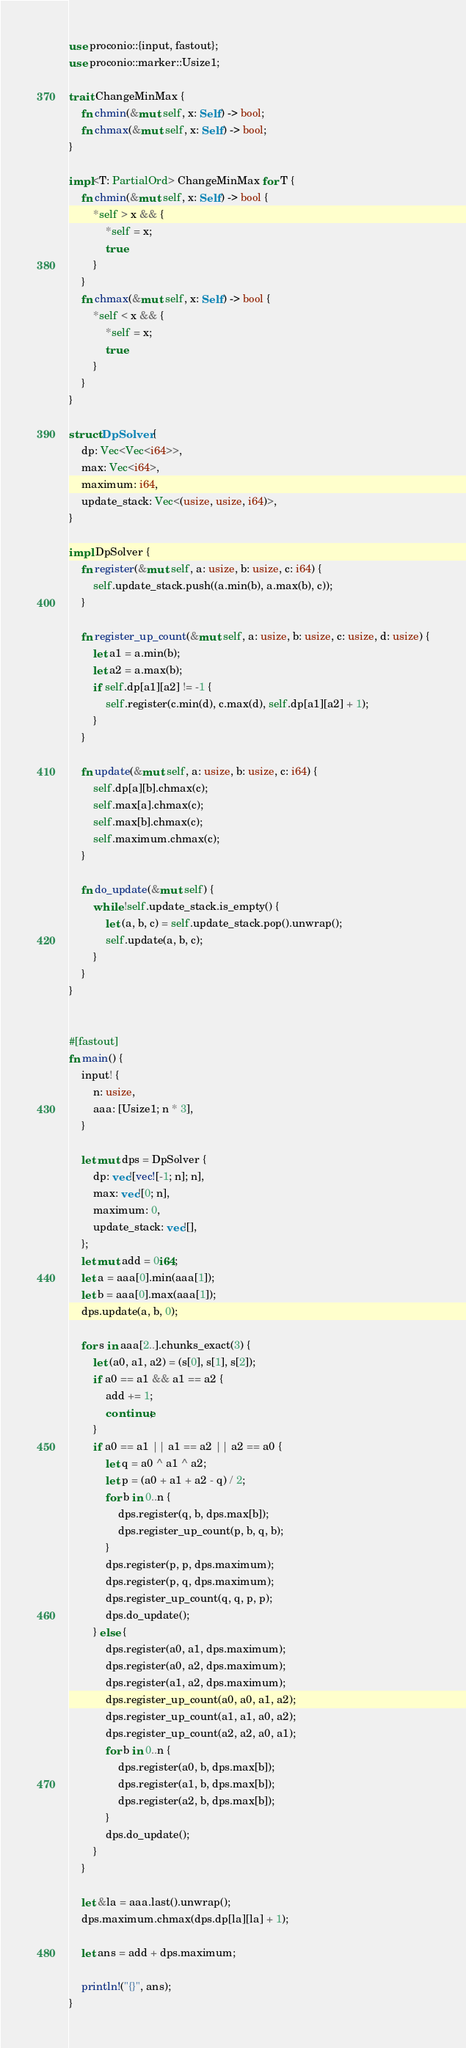<code> <loc_0><loc_0><loc_500><loc_500><_Rust_>use proconio::{input, fastout};
use proconio::marker::Usize1;

trait ChangeMinMax {
    fn chmin(&mut self, x: Self) -> bool;
    fn chmax(&mut self, x: Self) -> bool;
}

impl<T: PartialOrd> ChangeMinMax for T {
    fn chmin(&mut self, x: Self) -> bool {
        *self > x && {
            *self = x;
            true
        }
    }
    fn chmax(&mut self, x: Self) -> bool {
        *self < x && {
            *self = x;
            true
        }
    }
}

struct DpSolver {
    dp: Vec<Vec<i64>>,
    max: Vec<i64>,
    maximum: i64,
    update_stack: Vec<(usize, usize, i64)>,
}

impl DpSolver {
    fn register(&mut self, a: usize, b: usize, c: i64) {
        self.update_stack.push((a.min(b), a.max(b), c));
    }

    fn register_up_count(&mut self, a: usize, b: usize, c: usize, d: usize) {
        let a1 = a.min(b);
        let a2 = a.max(b);
        if self.dp[a1][a2] != -1 {
            self.register(c.min(d), c.max(d), self.dp[a1][a2] + 1);
        }
    }

    fn update(&mut self, a: usize, b: usize, c: i64) {
        self.dp[a][b].chmax(c);
        self.max[a].chmax(c);
        self.max[b].chmax(c);
        self.maximum.chmax(c);
    }

    fn do_update(&mut self) {
        while !self.update_stack.is_empty() {
            let (a, b, c) = self.update_stack.pop().unwrap();
            self.update(a, b, c);
        }
    }
}


#[fastout]
fn main() {
    input! {
        n: usize,
        aaa: [Usize1; n * 3],
    }

    let mut dps = DpSolver {
        dp: vec![vec![-1; n]; n],
        max: vec![0; n],
        maximum: 0,
        update_stack: vec![],
    };
    let mut add = 0i64;
    let a = aaa[0].min(aaa[1]);
    let b = aaa[0].max(aaa[1]);
    dps.update(a, b, 0);

    for s in aaa[2..].chunks_exact(3) {
        let (a0, a1, a2) = (s[0], s[1], s[2]);
        if a0 == a1 && a1 == a2 {
            add += 1;
            continue;
        }
        if a0 == a1 || a1 == a2 || a2 == a0 {
            let q = a0 ^ a1 ^ a2;
            let p = (a0 + a1 + a2 - q) / 2;
            for b in 0..n {
                dps.register(q, b, dps.max[b]);
                dps.register_up_count(p, b, q, b);
            }
            dps.register(p, p, dps.maximum);
            dps.register(p, q, dps.maximum);
            dps.register_up_count(q, q, p, p);
            dps.do_update();
        } else {
            dps.register(a0, a1, dps.maximum);
            dps.register(a0, a2, dps.maximum);
            dps.register(a1, a2, dps.maximum);
            dps.register_up_count(a0, a0, a1, a2);
            dps.register_up_count(a1, a1, a0, a2);
            dps.register_up_count(a2, a2, a0, a1);
            for b in 0..n {
                dps.register(a0, b, dps.max[b]);
                dps.register(a1, b, dps.max[b]);
                dps.register(a2, b, dps.max[b]);
            }
            dps.do_update();
        }
    }

    let &la = aaa.last().unwrap();
    dps.maximum.chmax(dps.dp[la][la] + 1);

    let ans = add + dps.maximum;

    println!("{}", ans);
}
</code> 